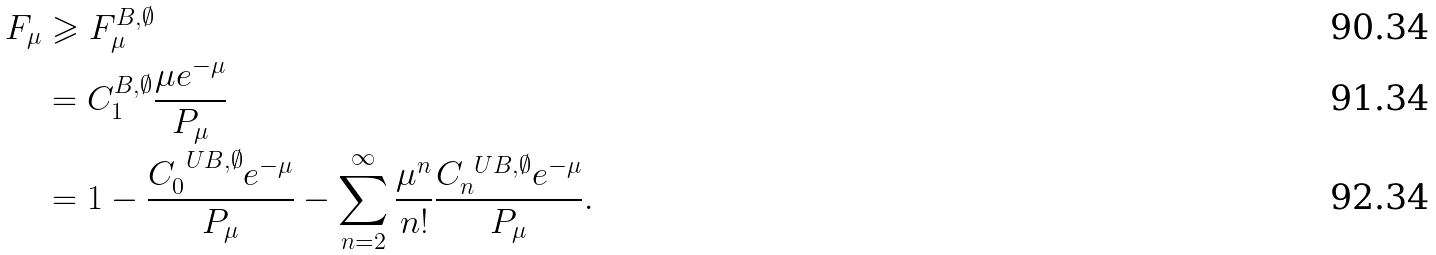<formula> <loc_0><loc_0><loc_500><loc_500>F _ { \mu } & \geqslant F _ { \mu } ^ { \L B , \emptyset } \\ & = C ^ { \L B , \emptyset } _ { 1 } \frac { \mu e ^ { - \mu } } { P _ { \mu } } \\ & = 1 - \frac { C _ { 0 } ^ { \ U B , \emptyset } e ^ { - \mu } } { P _ { \mu } } - \sum ^ { \infty } _ { n = 2 } \frac { \mu ^ { n } } { n ! } \frac { C _ { n } ^ { \ U B , \emptyset } e ^ { - \mu } } { P _ { \mu } } .</formula> 